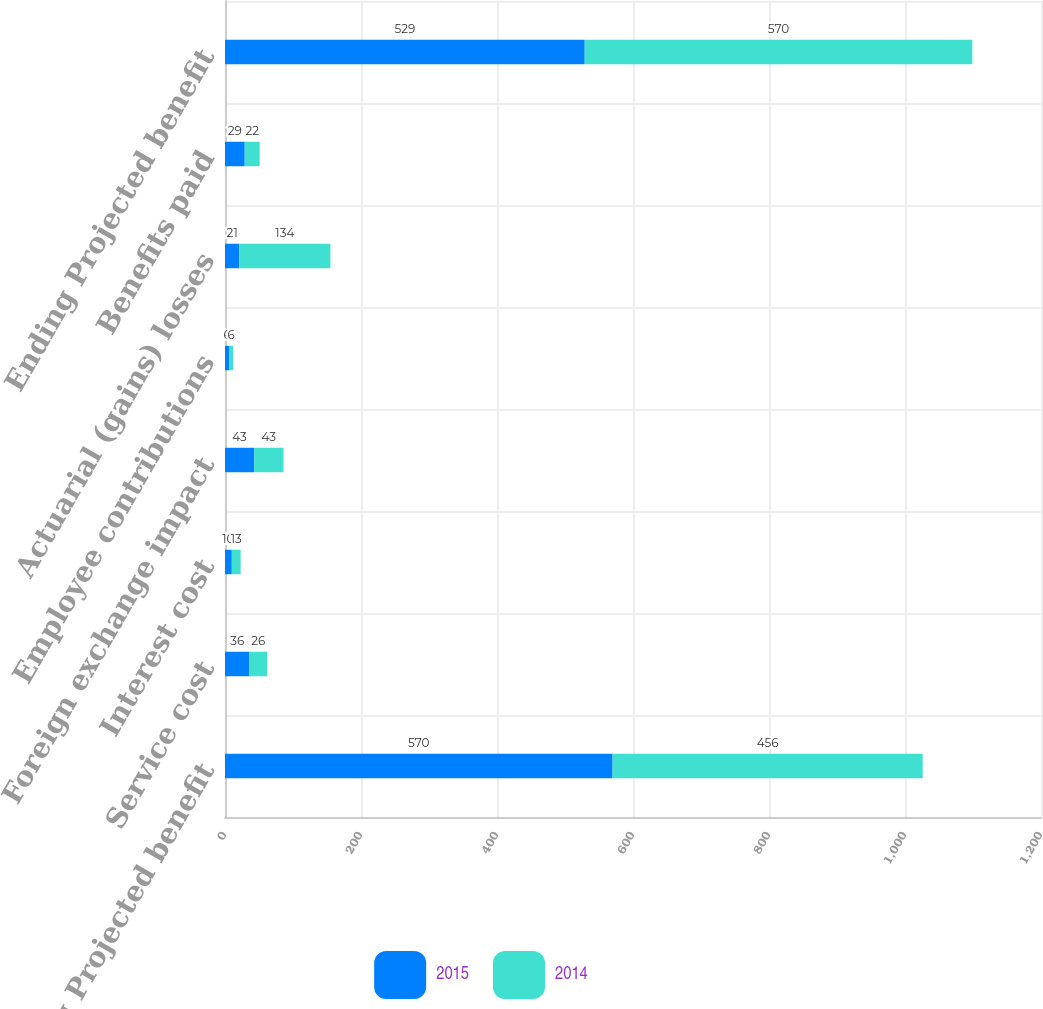Convert chart. <chart><loc_0><loc_0><loc_500><loc_500><stacked_bar_chart><ecel><fcel>Beginning Projected benefit<fcel>Service cost<fcel>Interest cost<fcel>Foreign exchange impact<fcel>Employee contributions<fcel>Actuarial (gains) losses<fcel>Benefits paid<fcel>Ending Projected benefit<nl><fcel>2015<fcel>570<fcel>36<fcel>10<fcel>43<fcel>6<fcel>21<fcel>29<fcel>529<nl><fcel>2014<fcel>456<fcel>26<fcel>13<fcel>43<fcel>6<fcel>134<fcel>22<fcel>570<nl></chart> 